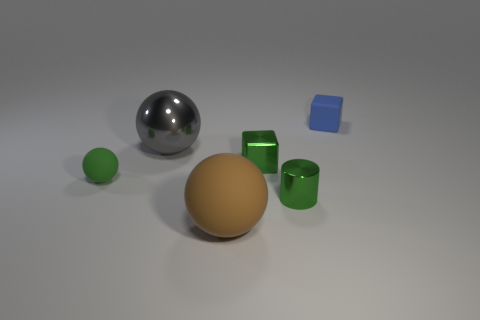Add 2 tiny purple cylinders. How many objects exist? 8 Subtract all blocks. How many objects are left? 4 Add 6 tiny metallic cubes. How many tiny metallic cubes exist? 7 Subtract 1 green blocks. How many objects are left? 5 Subtract all purple cubes. Subtract all green shiny things. How many objects are left? 4 Add 4 tiny blue matte blocks. How many tiny blue matte blocks are left? 5 